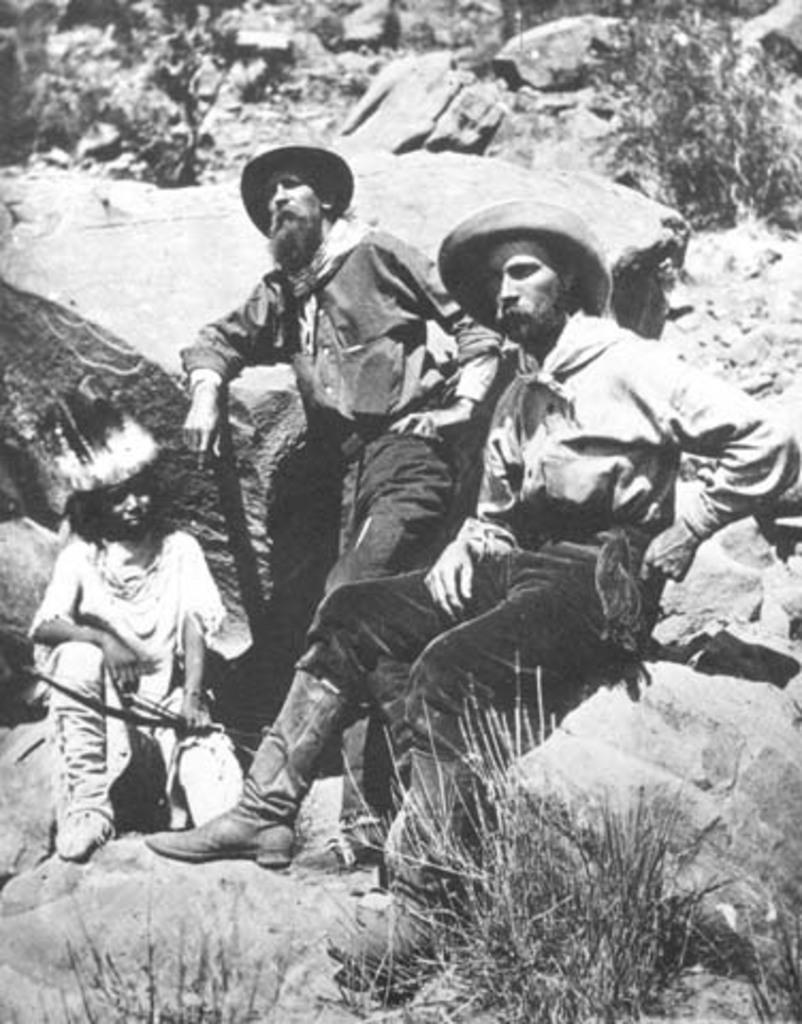Could you give a brief overview of what you see in this image? The image is in black and white, we can see there are three persons sitting on the rocks, in front there is grass. 